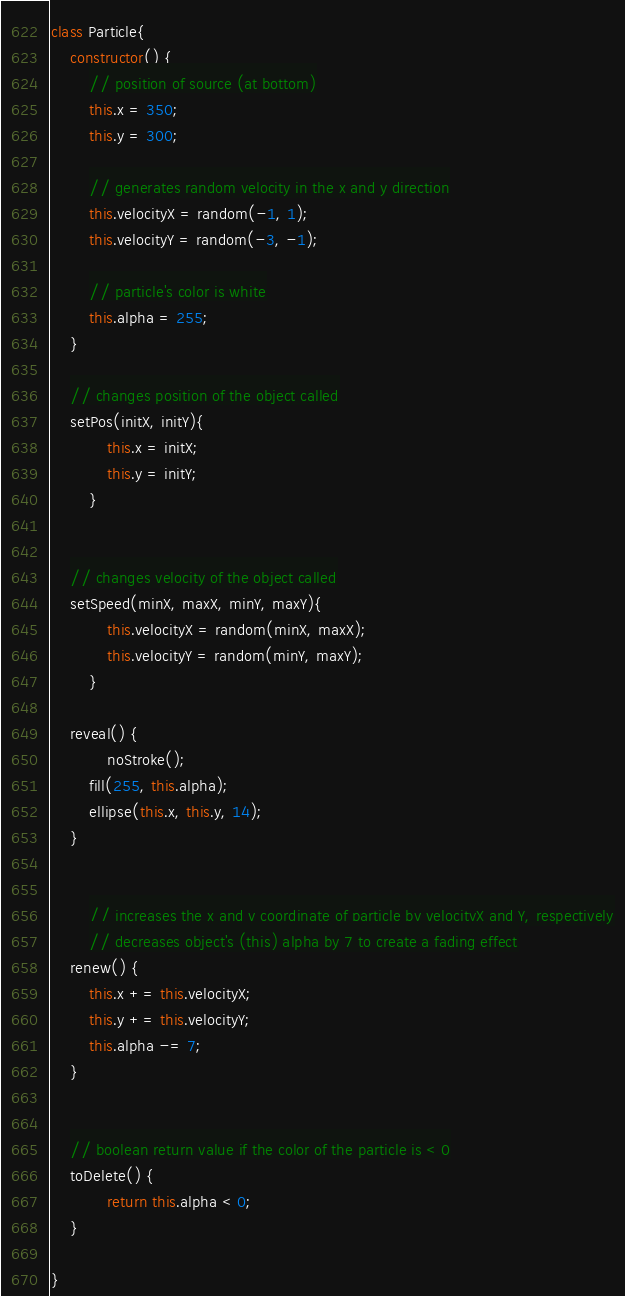<code> <loc_0><loc_0><loc_500><loc_500><_JavaScript_>class Particle{
	constructor() {
		// position of source (at bottom)
		this.x = 350;
		this.y = 300;

		// generates random velocity in the x and y direction
		this.velocityX = random(-1, 1);
		this.velocityY = random(-3, -1);

		// particle's color is white
		this.alpha = 255;  
	}
  	
	// changes position of the object called
	setPos(initX, initY){
      		this.x = initX;
     		this.y = initY;
    	}
  
    	
	// changes velocity of the object called
	setSpeed(minX, maxX, minY, maxY){
      		this.velocityX = random(minX, maxX);
      		this.velocityY = random(minY, maxY);
    	}
	
	reveal() {
        	noStroke();
		fill(255, this.alpha);
		ellipse(this.x, this.y, 14);
	}
	
	
    	// increases the x and y coordinate of particle by velocityX and Y, respectively
    	// decreases object's (this) alpha by 7 to create a fading effect
	renew() {
		this.x += this.velocityX;
		this.y += this.velocityY;
		this.alpha -= 7;
	}

	
	// boolean return value if the color of the particle is < 0
	toDelete() {
	      	return this.alpha < 0;
	}

}
</code> 